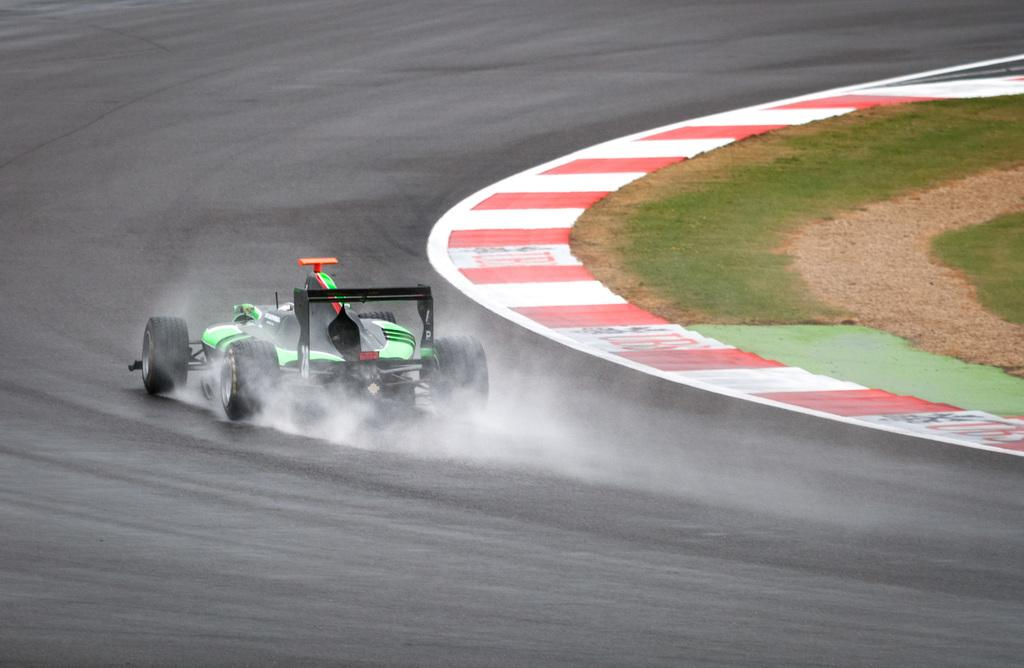What is the main subject of the image? The main subject of the image is a racing car. What is the racing car doing in the image? The racing car is moving on the road in the image. What type of terrain can be seen on the right side of the image? There is grass on the ground on the right side of the image. How many beds are visible in the image? There are no beds present in the image. What is the reaction of the grass to the racing car moving on the road? The grass does not have a reaction, as it is an inanimate object and cannot react to the racing car's movement. 